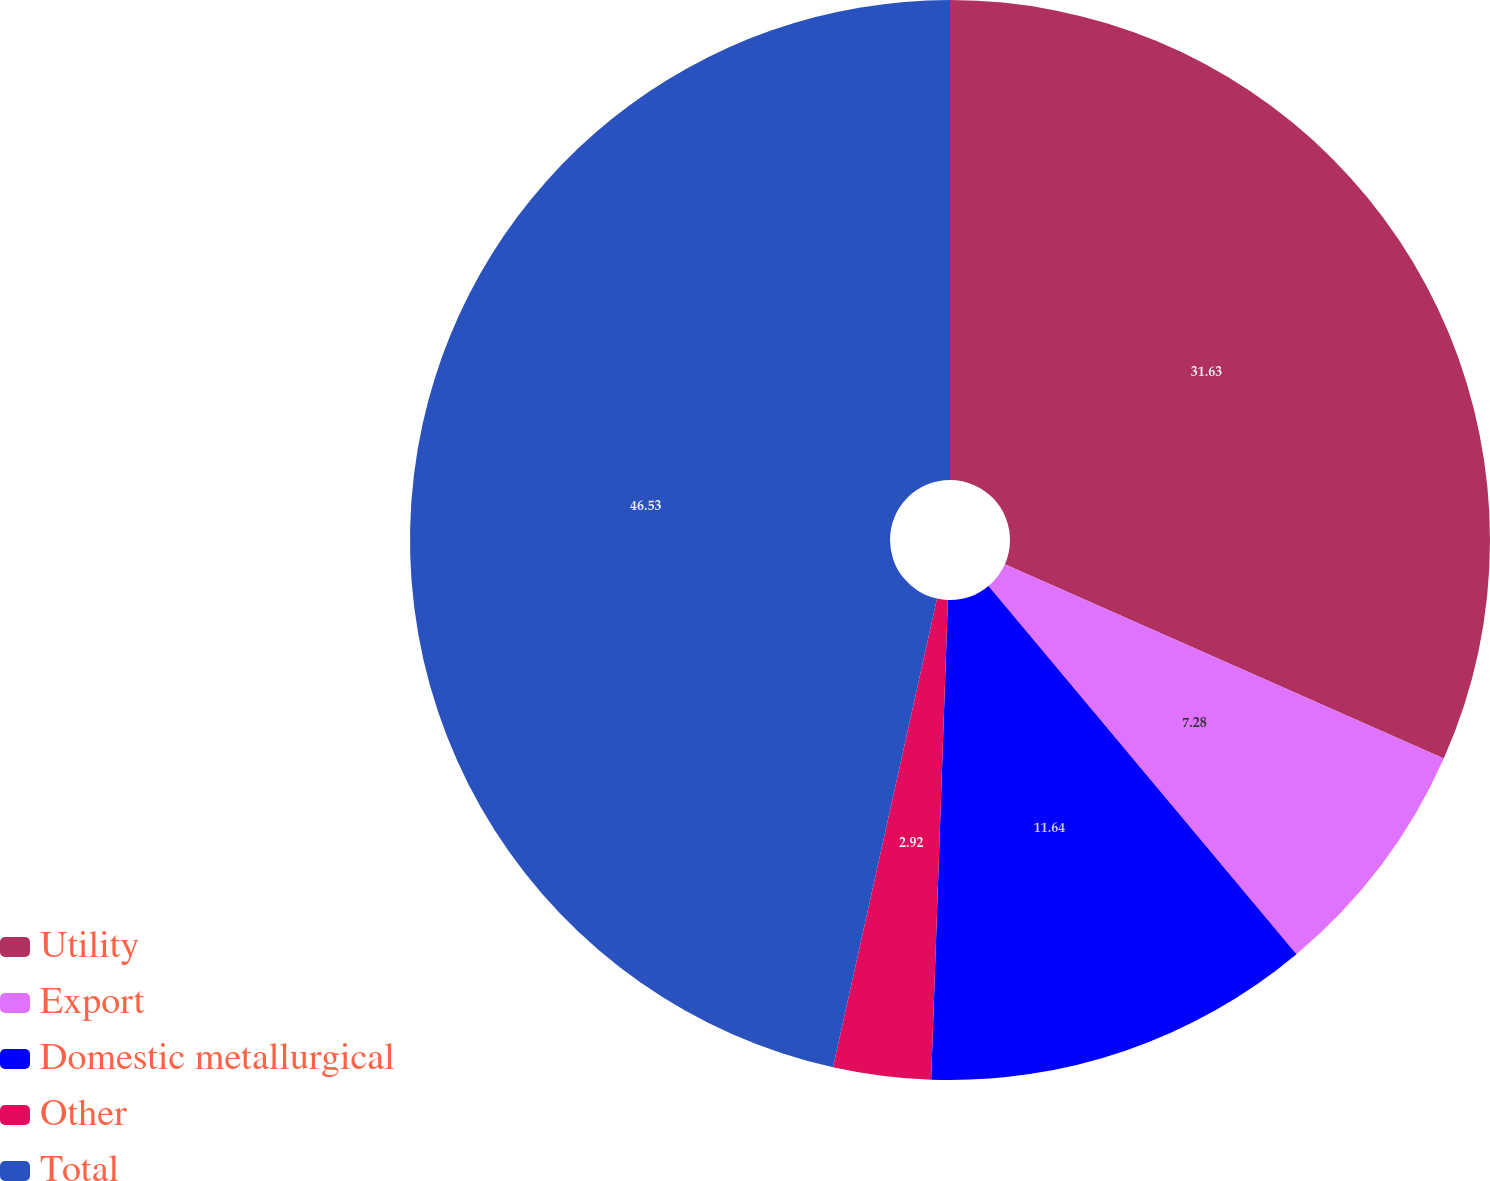Convert chart to OTSL. <chart><loc_0><loc_0><loc_500><loc_500><pie_chart><fcel>Utility<fcel>Export<fcel>Domestic metallurgical<fcel>Other<fcel>Total<nl><fcel>31.63%<fcel>7.28%<fcel>11.64%<fcel>2.92%<fcel>46.52%<nl></chart> 